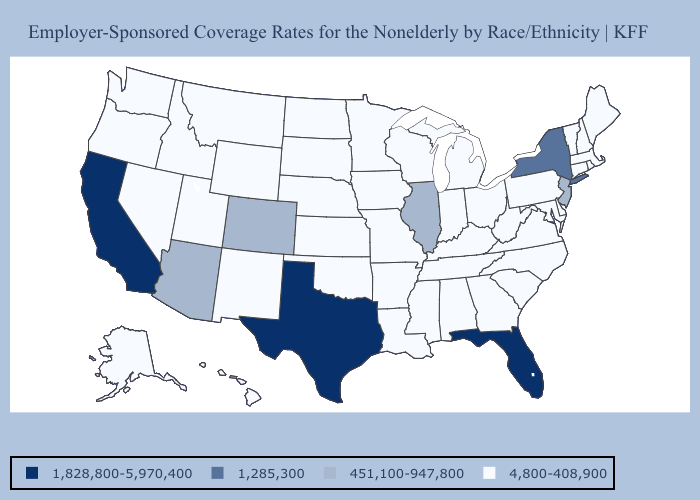What is the value of Michigan?
Keep it brief. 4,800-408,900. Does Massachusetts have the same value as New Jersey?
Be succinct. No. What is the value of Iowa?
Answer briefly. 4,800-408,900. Which states hav the highest value in the MidWest?
Give a very brief answer. Illinois. What is the value of Massachusetts?
Quick response, please. 4,800-408,900. Does Arkansas have the lowest value in the South?
Concise answer only. Yes. Which states hav the highest value in the West?
Be succinct. California. What is the value of Minnesota?
Short answer required. 4,800-408,900. Does Maryland have a higher value than Georgia?
Short answer required. No. What is the value of West Virginia?
Write a very short answer. 4,800-408,900. What is the highest value in the USA?
Short answer required. 1,828,800-5,970,400. Does Arkansas have the highest value in the South?
Concise answer only. No. What is the value of Hawaii?
Give a very brief answer. 4,800-408,900. What is the value of Illinois?
Give a very brief answer. 451,100-947,800. How many symbols are there in the legend?
Answer briefly. 4. 